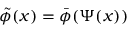Convert formula to latex. <formula><loc_0><loc_0><loc_500><loc_500>\tilde { \phi } ( x ) = \bar { \phi } ( \Psi ( x ) )</formula> 